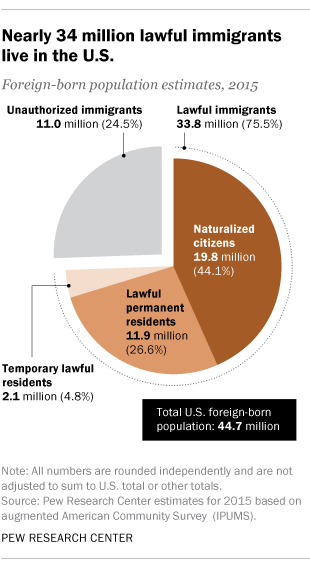Draw attention to some important aspects in this diagram. There are a total of four pies depicted in the chart. What is the difference in value between 17.5% of the first two largest slices of the chart? 